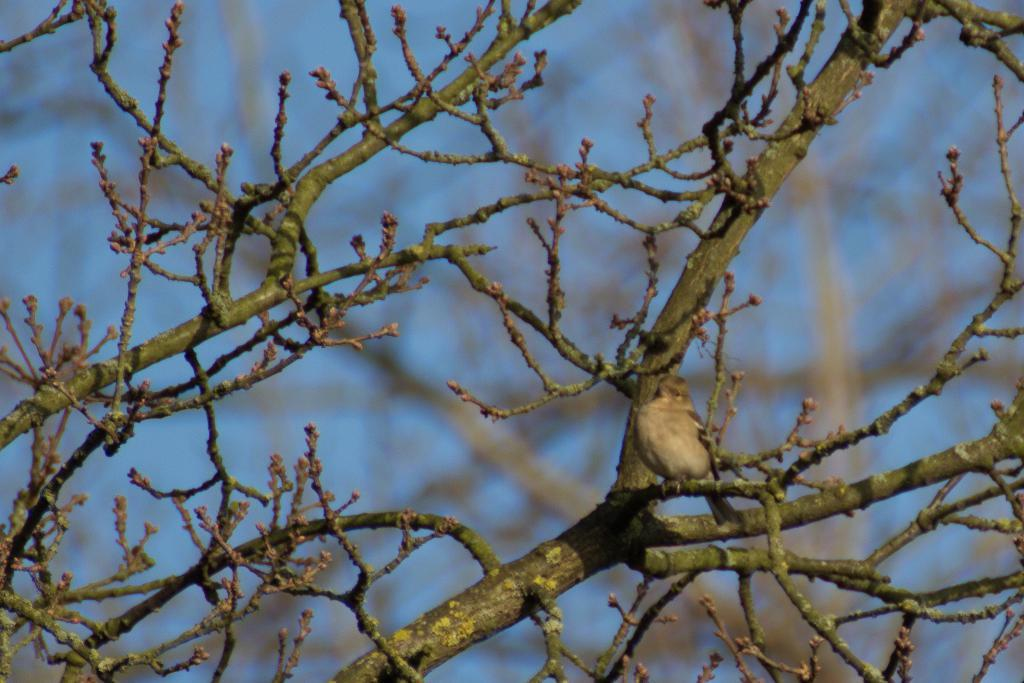What is present on the tree branch in the image? There is a bird on the tree branch in the image. Can you describe the main subject of the image? The main subject of the image is a tree branch with a bird on it. What can be observed about the background of the image? The background of the image is blurred. How many daughters does the bird on the tree branch have in the image? There is no information about the bird's daughters in the image, as it only shows a bird on a tree branch. What type of need is being used by the bird in the image? There is no mention of a need or any other tool being used by the bird in the image. 